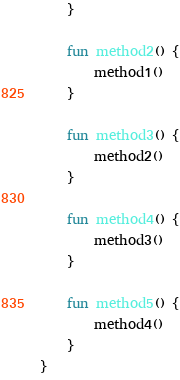Convert code to text. <code><loc_0><loc_0><loc_500><loc_500><_Kotlin_>    }

    fun method2() {
        method1()
    }

    fun method3() {
        method2()
    }

    fun method4() {
        method3()
    }

    fun method5() {
        method4()
    }
}
</code> 